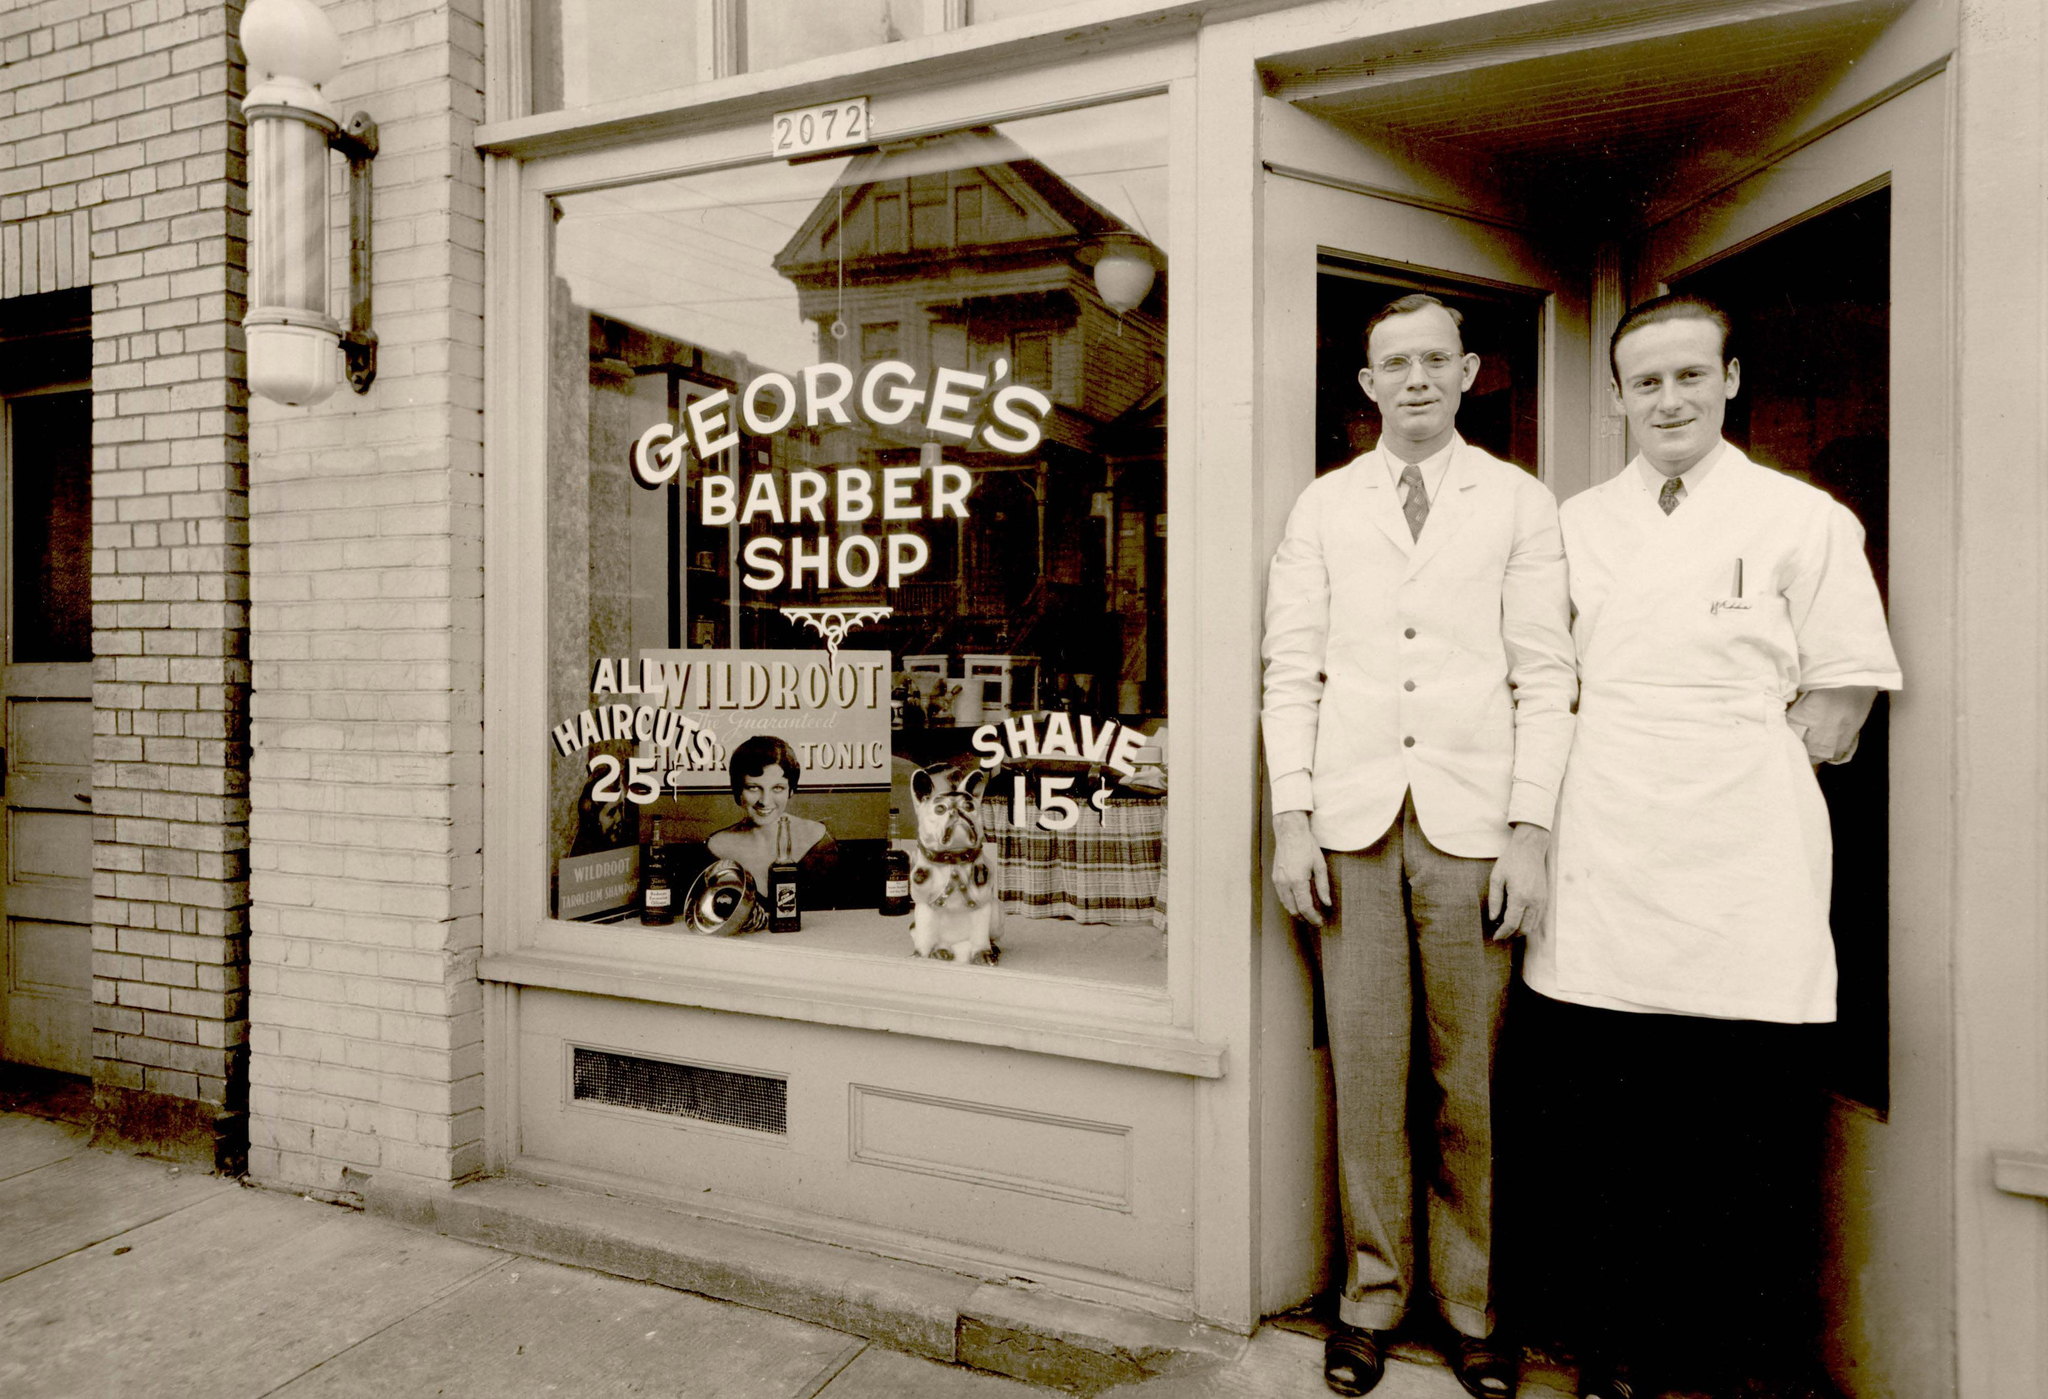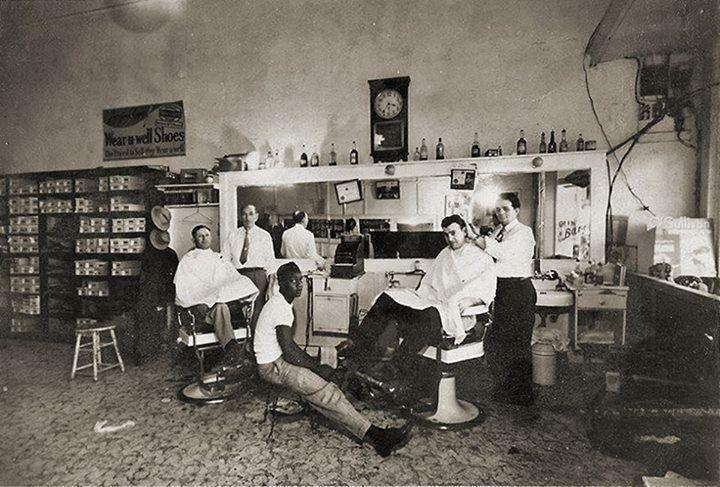The first image is the image on the left, the second image is the image on the right. Evaluate the accuracy of this statement regarding the images: "Five barbers are working with customers seated in chairs.". Is it true? Answer yes or no. No. The first image is the image on the left, the second image is the image on the right. Considering the images on both sides, is "There are exactly two men sitting in barbers chairs in the image on the right." valid? Answer yes or no. Yes. 